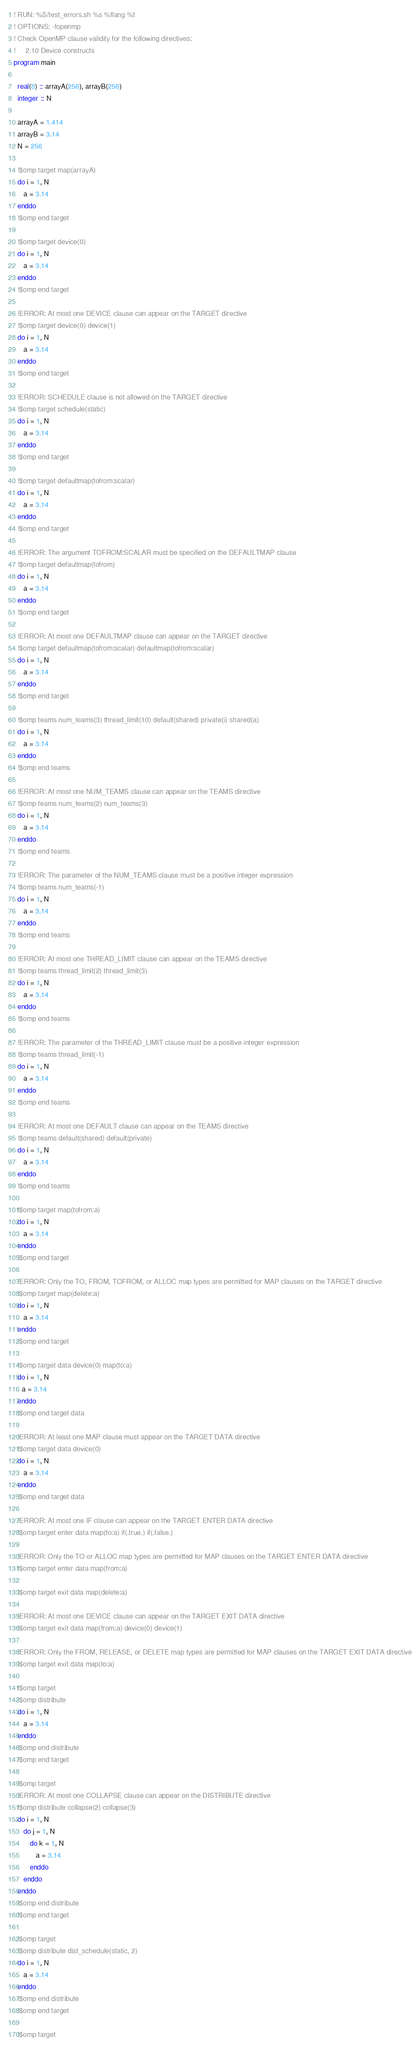Convert code to text. <code><loc_0><loc_0><loc_500><loc_500><_FORTRAN_>! RUN: %S/test_errors.sh %s %flang %t
! OPTIONS: -fopenmp
! Check OpenMP clause validity for the following directives:
!     2.10 Device constructs
program main

  real(8) :: arrayA(256), arrayB(256)
  integer :: N

  arrayA = 1.414
  arrayB = 3.14
  N = 256

  !$omp target map(arrayA)
  do i = 1, N
     a = 3.14
  enddo
  !$omp end target

  !$omp target device(0)
  do i = 1, N
     a = 3.14
  enddo
  !$omp end target

  !ERROR: At most one DEVICE clause can appear on the TARGET directive
  !$omp target device(0) device(1)
  do i = 1, N
     a = 3.14
  enddo
  !$omp end target

  !ERROR: SCHEDULE clause is not allowed on the TARGET directive
  !$omp target schedule(static)
  do i = 1, N
     a = 3.14
  enddo
  !$omp end target

  !$omp target defaultmap(tofrom:scalar)
  do i = 1, N
     a = 3.14
  enddo
  !$omp end target

  !ERROR: The argument TOFROM:SCALAR must be specified on the DEFAULTMAP clause
  !$omp target defaultmap(tofrom)
  do i = 1, N
     a = 3.14
  enddo
  !$omp end target

  !ERROR: At most one DEFAULTMAP clause can appear on the TARGET directive
  !$omp target defaultmap(tofrom:scalar) defaultmap(tofrom:scalar)
  do i = 1, N
     a = 3.14
  enddo
  !$omp end target

  !$omp teams num_teams(3) thread_limit(10) default(shared) private(i) shared(a)
  do i = 1, N
     a = 3.14
  enddo
  !$omp end teams

  !ERROR: At most one NUM_TEAMS clause can appear on the TEAMS directive
  !$omp teams num_teams(2) num_teams(3)
  do i = 1, N
     a = 3.14
  enddo
  !$omp end teams

  !ERROR: The parameter of the NUM_TEAMS clause must be a positive integer expression
  !$omp teams num_teams(-1)
  do i = 1, N
     a = 3.14
  enddo
  !$omp end teams

  !ERROR: At most one THREAD_LIMIT clause can appear on the TEAMS directive
  !$omp teams thread_limit(2) thread_limit(3)
  do i = 1, N
     a = 3.14
  enddo
  !$omp end teams

  !ERROR: The parameter of the THREAD_LIMIT clause must be a positive integer expression
  !$omp teams thread_limit(-1)
  do i = 1, N
     a = 3.14
  enddo
  !$omp end teams

  !ERROR: At most one DEFAULT clause can appear on the TEAMS directive
  !$omp teams default(shared) default(private)
  do i = 1, N
     a = 3.14
  enddo
  !$omp end teams

  !$omp target map(tofrom:a)
  do i = 1, N
     a = 3.14
  enddo
  !$omp end target

  !ERROR: Only the TO, FROM, TOFROM, or ALLOC map types are permitted for MAP clauses on the TARGET directive
  !$omp target map(delete:a)
  do i = 1, N
     a = 3.14
  enddo
  !$omp end target

  !$omp target data device(0) map(to:a)
  do i = 1, N
    a = 3.14
  enddo
  !$omp end target data

  !ERROR: At least one MAP clause must appear on the TARGET DATA directive
  !$omp target data device(0)
  do i = 1, N
     a = 3.14
  enddo
  !$omp end target data

  !ERROR: At most one IF clause can appear on the TARGET ENTER DATA directive
  !$omp target enter data map(to:a) if(.true.) if(.false.)

  !ERROR: Only the TO or ALLOC map types are permitted for MAP clauses on the TARGET ENTER DATA directive
  !$omp target enter data map(from:a)

  !$omp target exit data map(delete:a)

  !ERROR: At most one DEVICE clause can appear on the TARGET EXIT DATA directive
  !$omp target exit data map(from:a) device(0) device(1)

  !ERROR: Only the FROM, RELEASE, or DELETE map types are permitted for MAP clauses on the TARGET EXIT DATA directive
  !$omp target exit data map(to:a)

  !$omp target
  !$omp distribute
  do i = 1, N
     a = 3.14
  enddo
  !$omp end distribute
  !$omp end target

  !$omp target
  !ERROR: At most one COLLAPSE clause can appear on the DISTRIBUTE directive
  !$omp distribute collapse(2) collapse(3)
  do i = 1, N
     do j = 1, N
        do k = 1, N
           a = 3.14
        enddo
     enddo
  enddo
  !$omp end distribute
  !$omp end target

  !$omp target
  !$omp distribute dist_schedule(static, 2)
  do i = 1, N
     a = 3.14
  enddo
  !$omp end distribute
  !$omp end target

  !$omp target</code> 